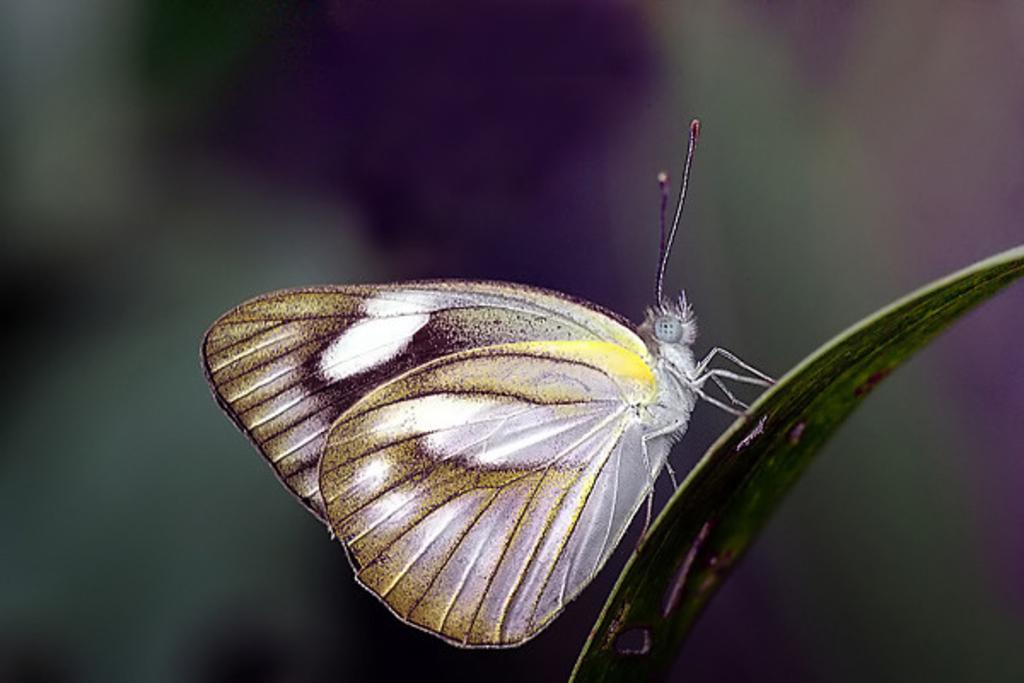What is the main subject of the image? There is a butterfly in the image. Where is the butterfly located? The butterfly is on a leaf. Can you describe the background of the image? The background of the image is blurred. What type of record can be seen playing in the background of the image? There is no record present in the image; it features a butterfly on a leaf with a blurred background. Can you tell me how many snakes are visible in the image? There are no snakes visible in the image; it features a butterfly on a leaf with a blurred background. 